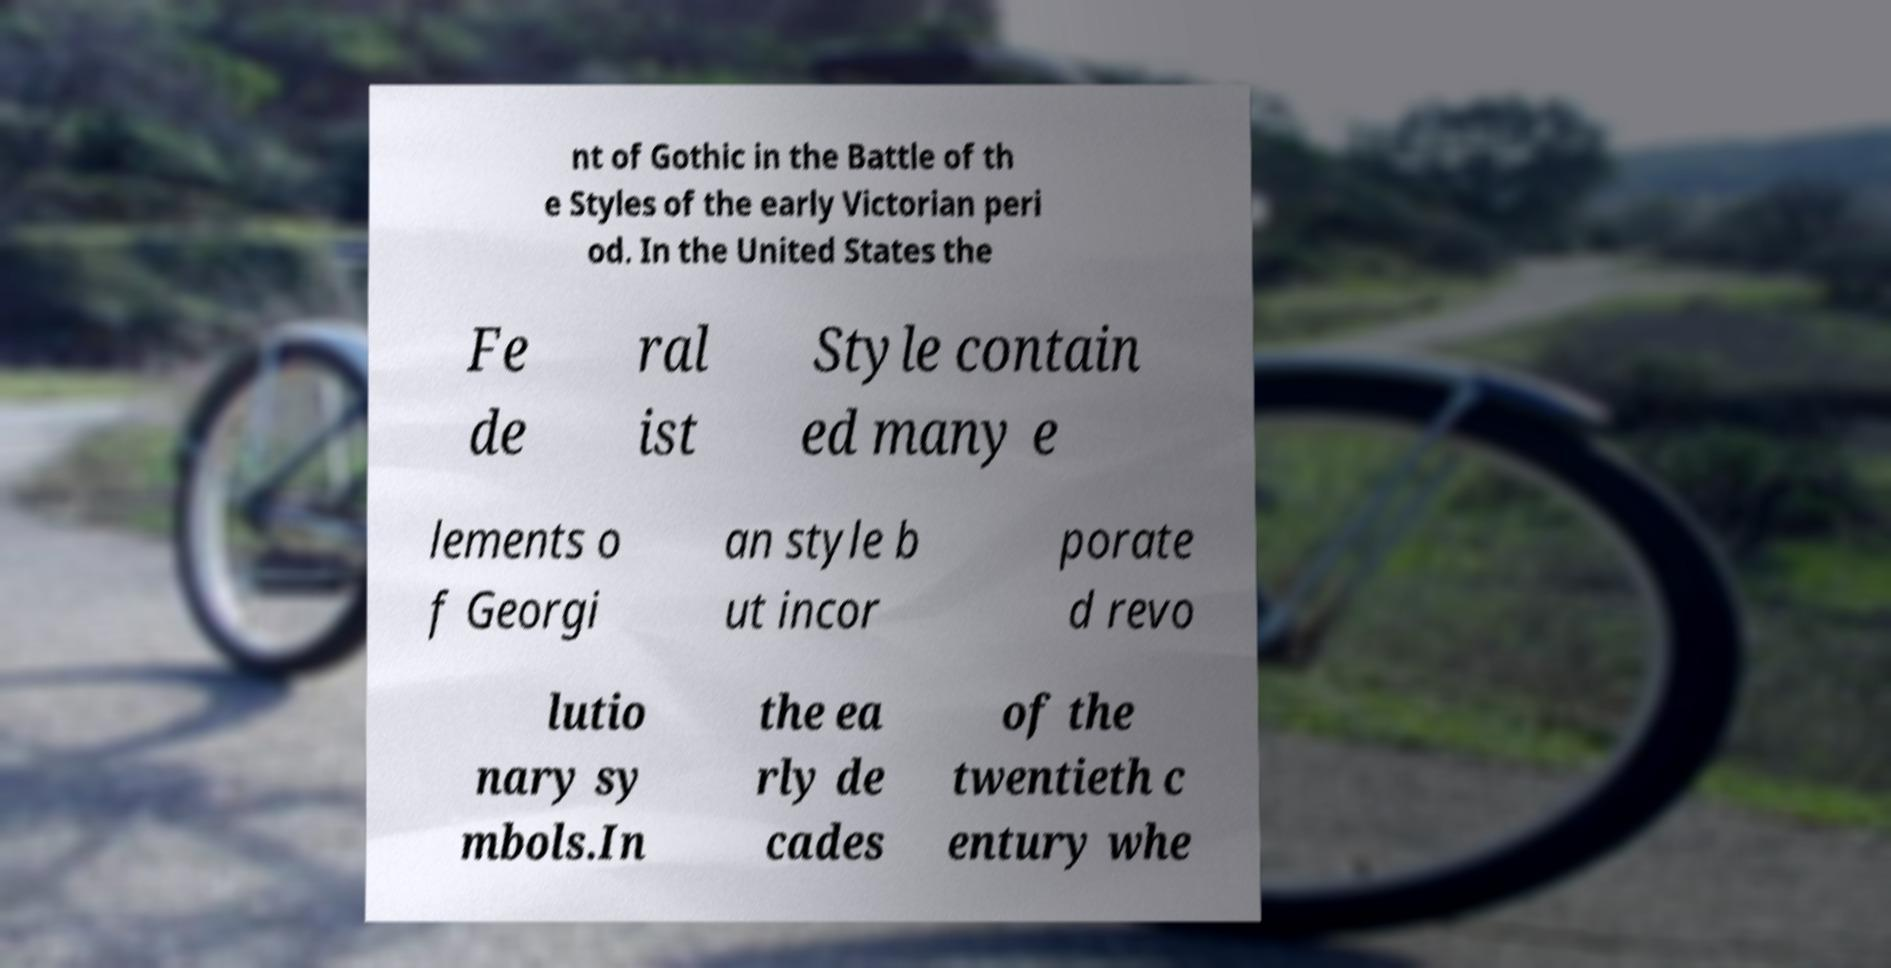Can you read and provide the text displayed in the image?This photo seems to have some interesting text. Can you extract and type it out for me? nt of Gothic in the Battle of th e Styles of the early Victorian peri od. In the United States the Fe de ral ist Style contain ed many e lements o f Georgi an style b ut incor porate d revo lutio nary sy mbols.In the ea rly de cades of the twentieth c entury whe 